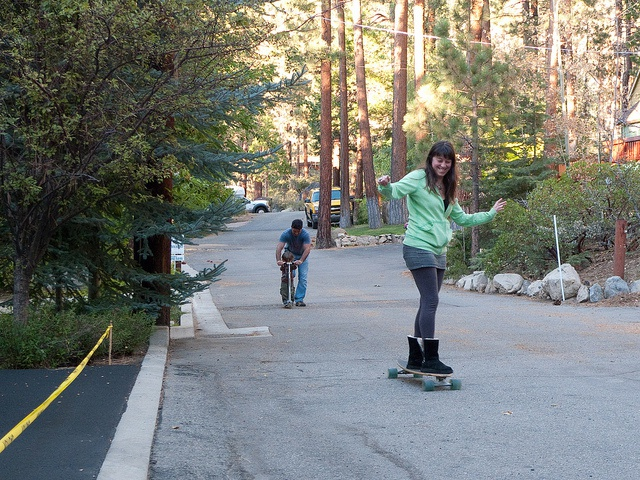Describe the objects in this image and their specific colors. I can see people in black, gray, and turquoise tones, people in black, blue, gray, and navy tones, car in black, gray, and ivory tones, truck in black, gray, and darkgray tones, and skateboard in black, gray, teal, and darkgray tones in this image. 